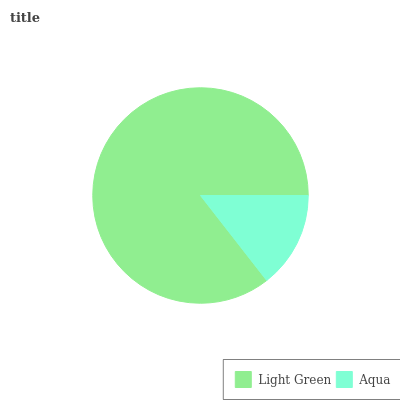Is Aqua the minimum?
Answer yes or no. Yes. Is Light Green the maximum?
Answer yes or no. Yes. Is Aqua the maximum?
Answer yes or no. No. Is Light Green greater than Aqua?
Answer yes or no. Yes. Is Aqua less than Light Green?
Answer yes or no. Yes. Is Aqua greater than Light Green?
Answer yes or no. No. Is Light Green less than Aqua?
Answer yes or no. No. Is Light Green the high median?
Answer yes or no. Yes. Is Aqua the low median?
Answer yes or no. Yes. Is Aqua the high median?
Answer yes or no. No. Is Light Green the low median?
Answer yes or no. No. 